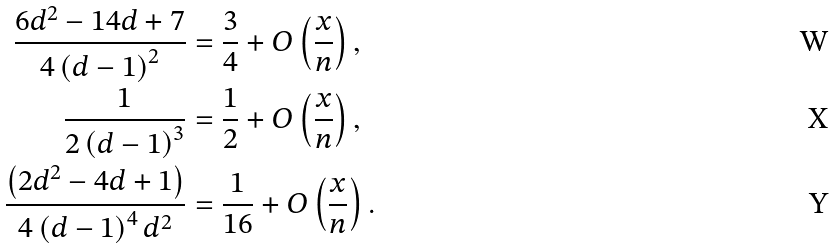Convert formula to latex. <formula><loc_0><loc_0><loc_500><loc_500>\frac { 6 d ^ { 2 } - 1 4 d + 7 } { 4 \left ( d - 1 \right ) ^ { 2 } } & = \frac { 3 } { 4 } + O \left ( \frac { x } { n } \right ) , \\ \frac { 1 } { 2 \left ( d - 1 \right ) ^ { 3 } } & = \frac { 1 } { 2 } + O \left ( \frac { x } { n } \right ) , \\ \frac { \left ( 2 d ^ { 2 } - 4 d + 1 \right ) } { 4 \left ( d - 1 \right ) ^ { 4 } d ^ { 2 } } & = \frac { 1 } { 1 6 } + O \left ( \frac { x } { n } \right ) .</formula> 